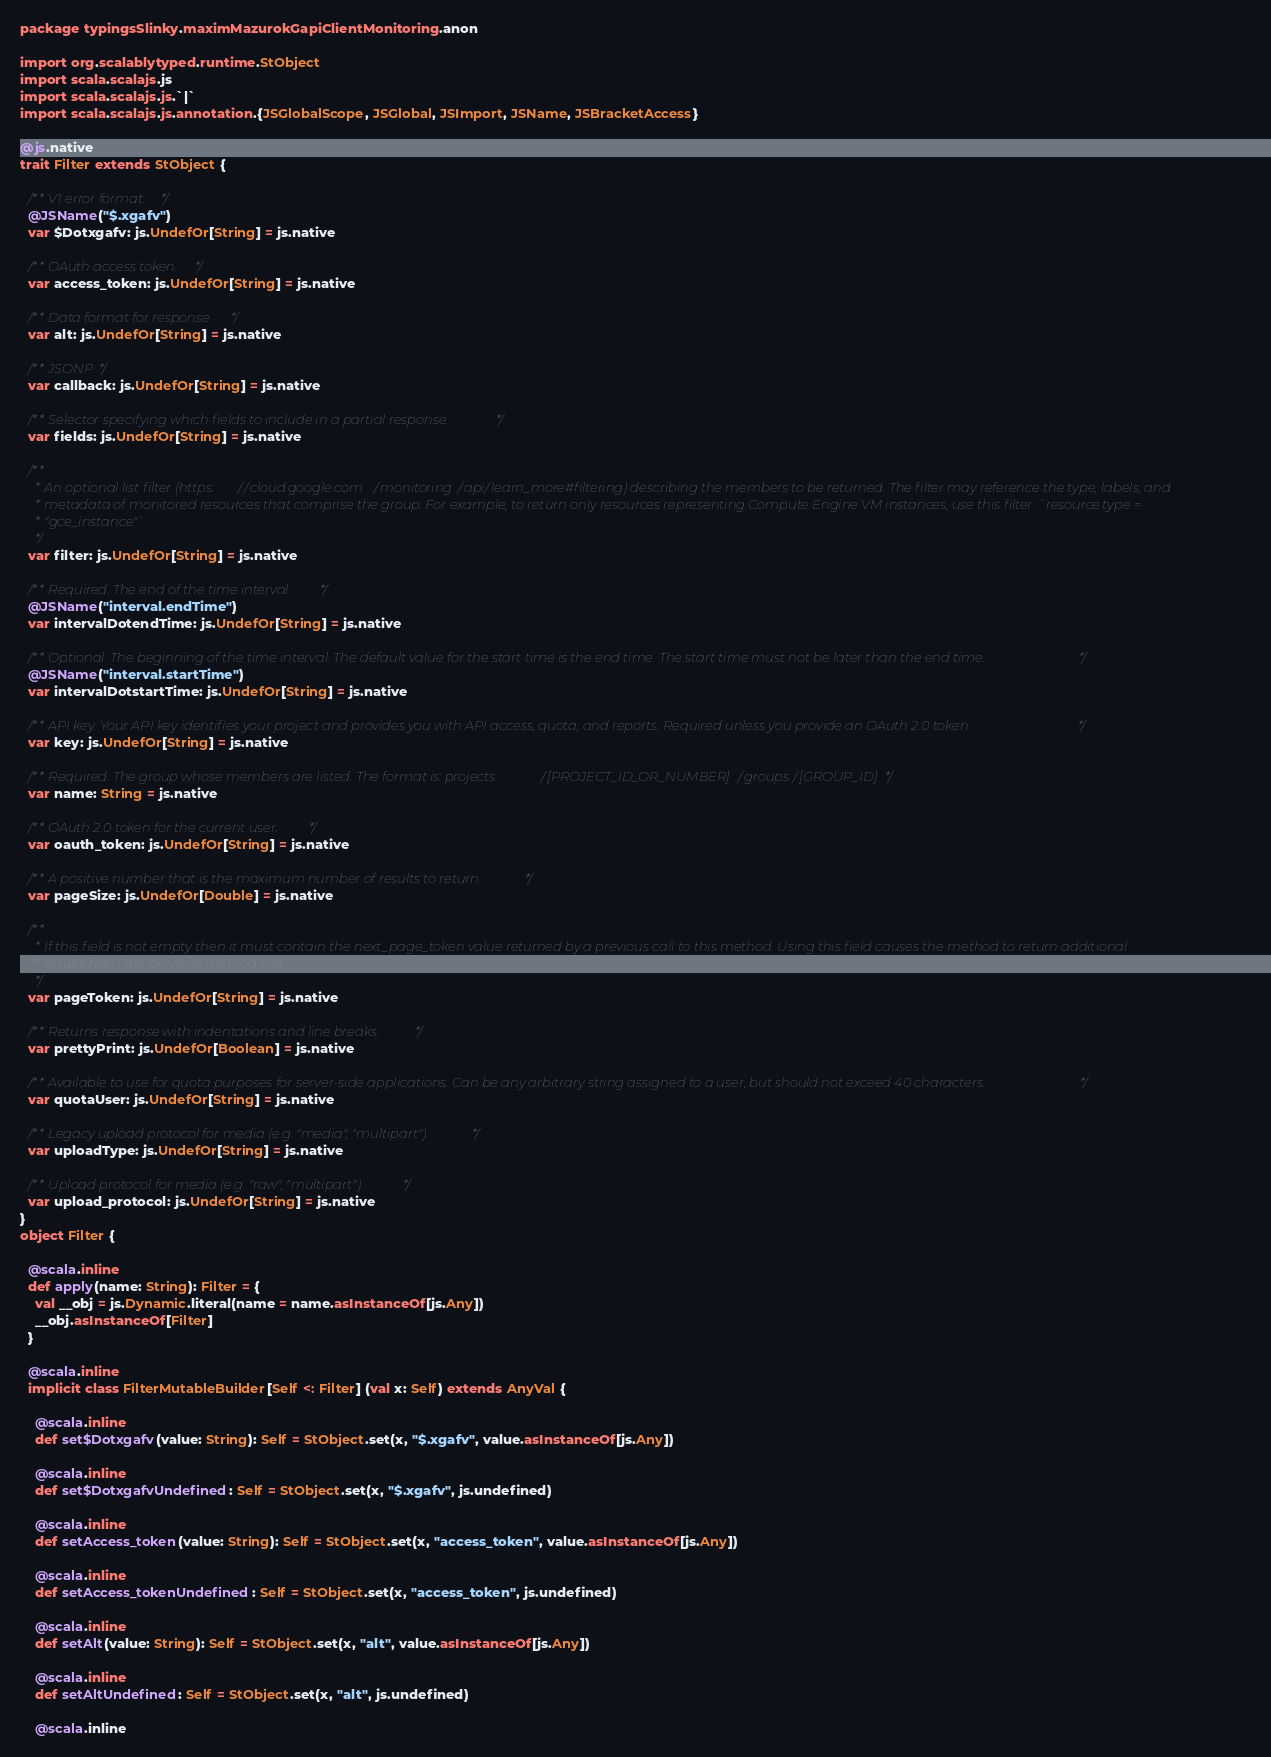<code> <loc_0><loc_0><loc_500><loc_500><_Scala_>package typingsSlinky.maximMazurokGapiClientMonitoring.anon

import org.scalablytyped.runtime.StObject
import scala.scalajs.js
import scala.scalajs.js.`|`
import scala.scalajs.js.annotation.{JSGlobalScope, JSGlobal, JSImport, JSName, JSBracketAccess}

@js.native
trait Filter extends StObject {
  
  /** V1 error format. */
  @JSName("$.xgafv")
  var $Dotxgafv: js.UndefOr[String] = js.native
  
  /** OAuth access token. */
  var access_token: js.UndefOr[String] = js.native
  
  /** Data format for response. */
  var alt: js.UndefOr[String] = js.native
  
  /** JSONP */
  var callback: js.UndefOr[String] = js.native
  
  /** Selector specifying which fields to include in a partial response. */
  var fields: js.UndefOr[String] = js.native
  
  /**
    * An optional list filter (https://cloud.google.com/monitoring/api/learn_more#filtering) describing the members to be returned. The filter may reference the type, labels, and
    * metadata of monitored resources that comprise the group. For example, to return only resources representing Compute Engine VM instances, use this filter: `resource.type =
    * "gce_instance"`
    */
  var filter: js.UndefOr[String] = js.native
  
  /** Required. The end of the time interval. */
  @JSName("interval.endTime")
  var intervalDotendTime: js.UndefOr[String] = js.native
  
  /** Optional. The beginning of the time interval. The default value for the start time is the end time. The start time must not be later than the end time. */
  @JSName("interval.startTime")
  var intervalDotstartTime: js.UndefOr[String] = js.native
  
  /** API key. Your API key identifies your project and provides you with API access, quota, and reports. Required unless you provide an OAuth 2.0 token. */
  var key: js.UndefOr[String] = js.native
  
  /** Required. The group whose members are listed. The format is: projects/[PROJECT_ID_OR_NUMBER]/groups/[GROUP_ID] */
  var name: String = js.native
  
  /** OAuth 2.0 token for the current user. */
  var oauth_token: js.UndefOr[String] = js.native
  
  /** A positive number that is the maximum number of results to return. */
  var pageSize: js.UndefOr[Double] = js.native
  
  /**
    * If this field is not empty then it must contain the next_page_token value returned by a previous call to this method. Using this field causes the method to return additional
    * results from the previous method call.
    */
  var pageToken: js.UndefOr[String] = js.native
  
  /** Returns response with indentations and line breaks. */
  var prettyPrint: js.UndefOr[Boolean] = js.native
  
  /** Available to use for quota purposes for server-side applications. Can be any arbitrary string assigned to a user, but should not exceed 40 characters. */
  var quotaUser: js.UndefOr[String] = js.native
  
  /** Legacy upload protocol for media (e.g. "media", "multipart"). */
  var uploadType: js.UndefOr[String] = js.native
  
  /** Upload protocol for media (e.g. "raw", "multipart"). */
  var upload_protocol: js.UndefOr[String] = js.native
}
object Filter {
  
  @scala.inline
  def apply(name: String): Filter = {
    val __obj = js.Dynamic.literal(name = name.asInstanceOf[js.Any])
    __obj.asInstanceOf[Filter]
  }
  
  @scala.inline
  implicit class FilterMutableBuilder[Self <: Filter] (val x: Self) extends AnyVal {
    
    @scala.inline
    def set$Dotxgafv(value: String): Self = StObject.set(x, "$.xgafv", value.asInstanceOf[js.Any])
    
    @scala.inline
    def set$DotxgafvUndefined: Self = StObject.set(x, "$.xgafv", js.undefined)
    
    @scala.inline
    def setAccess_token(value: String): Self = StObject.set(x, "access_token", value.asInstanceOf[js.Any])
    
    @scala.inline
    def setAccess_tokenUndefined: Self = StObject.set(x, "access_token", js.undefined)
    
    @scala.inline
    def setAlt(value: String): Self = StObject.set(x, "alt", value.asInstanceOf[js.Any])
    
    @scala.inline
    def setAltUndefined: Self = StObject.set(x, "alt", js.undefined)
    
    @scala.inline</code> 